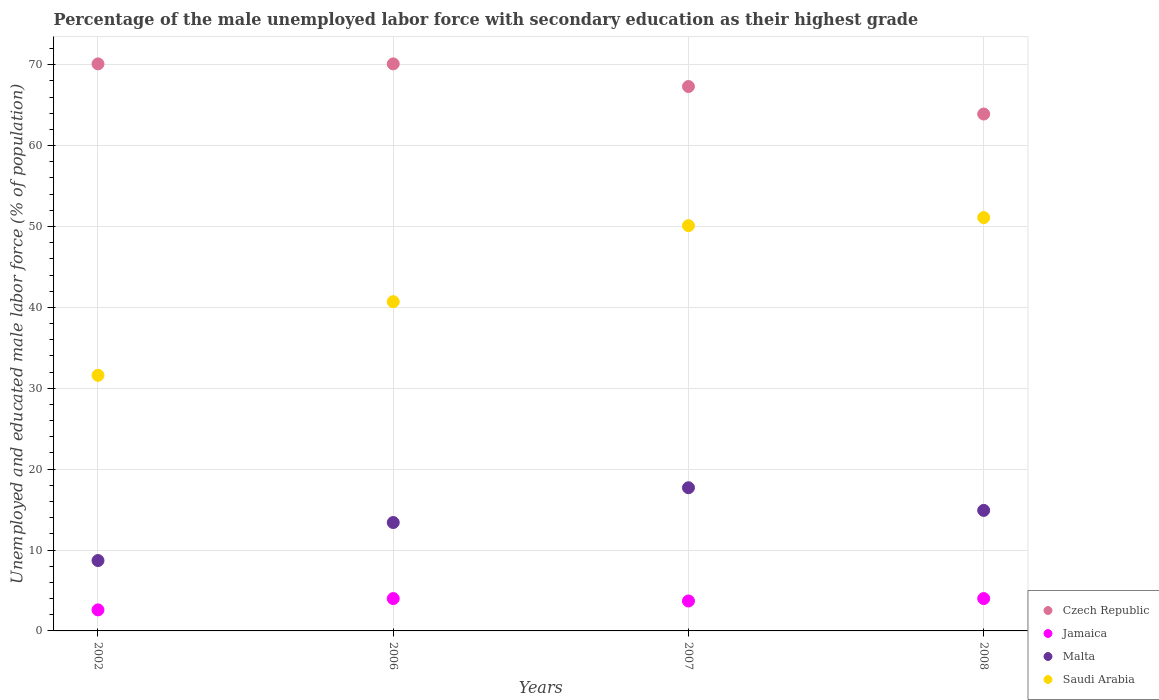What is the percentage of the unemployed male labor force with secondary education in Saudi Arabia in 2002?
Provide a succinct answer. 31.6. Across all years, what is the maximum percentage of the unemployed male labor force with secondary education in Czech Republic?
Your response must be concise. 70.1. Across all years, what is the minimum percentage of the unemployed male labor force with secondary education in Jamaica?
Ensure brevity in your answer.  2.6. In which year was the percentage of the unemployed male labor force with secondary education in Saudi Arabia minimum?
Your answer should be very brief. 2002. What is the total percentage of the unemployed male labor force with secondary education in Czech Republic in the graph?
Offer a terse response. 271.4. What is the difference between the percentage of the unemployed male labor force with secondary education in Malta in 2006 and that in 2008?
Ensure brevity in your answer.  -1.5. What is the difference between the percentage of the unemployed male labor force with secondary education in Czech Republic in 2007 and the percentage of the unemployed male labor force with secondary education in Malta in 2008?
Give a very brief answer. 52.4. What is the average percentage of the unemployed male labor force with secondary education in Czech Republic per year?
Offer a terse response. 67.85. In the year 2007, what is the difference between the percentage of the unemployed male labor force with secondary education in Malta and percentage of the unemployed male labor force with secondary education in Jamaica?
Offer a terse response. 14. In how many years, is the percentage of the unemployed male labor force with secondary education in Malta greater than 44 %?
Give a very brief answer. 0. What is the ratio of the percentage of the unemployed male labor force with secondary education in Jamaica in 2002 to that in 2008?
Your response must be concise. 0.65. What is the difference between the highest and the lowest percentage of the unemployed male labor force with secondary education in Malta?
Offer a terse response. 9. Is the percentage of the unemployed male labor force with secondary education in Malta strictly greater than the percentage of the unemployed male labor force with secondary education in Saudi Arabia over the years?
Provide a succinct answer. No. How many years are there in the graph?
Your answer should be very brief. 4. What is the difference between two consecutive major ticks on the Y-axis?
Ensure brevity in your answer.  10. Are the values on the major ticks of Y-axis written in scientific E-notation?
Your answer should be very brief. No. Where does the legend appear in the graph?
Your answer should be very brief. Bottom right. How many legend labels are there?
Offer a very short reply. 4. How are the legend labels stacked?
Keep it short and to the point. Vertical. What is the title of the graph?
Provide a short and direct response. Percentage of the male unemployed labor force with secondary education as their highest grade. What is the label or title of the Y-axis?
Ensure brevity in your answer.  Unemployed and educated male labor force (% of population). What is the Unemployed and educated male labor force (% of population) of Czech Republic in 2002?
Provide a short and direct response. 70.1. What is the Unemployed and educated male labor force (% of population) of Jamaica in 2002?
Make the answer very short. 2.6. What is the Unemployed and educated male labor force (% of population) of Malta in 2002?
Provide a short and direct response. 8.7. What is the Unemployed and educated male labor force (% of population) of Saudi Arabia in 2002?
Provide a succinct answer. 31.6. What is the Unemployed and educated male labor force (% of population) in Czech Republic in 2006?
Provide a succinct answer. 70.1. What is the Unemployed and educated male labor force (% of population) of Jamaica in 2006?
Provide a succinct answer. 4. What is the Unemployed and educated male labor force (% of population) in Malta in 2006?
Keep it short and to the point. 13.4. What is the Unemployed and educated male labor force (% of population) of Saudi Arabia in 2006?
Make the answer very short. 40.7. What is the Unemployed and educated male labor force (% of population) in Czech Republic in 2007?
Keep it short and to the point. 67.3. What is the Unemployed and educated male labor force (% of population) in Jamaica in 2007?
Your answer should be compact. 3.7. What is the Unemployed and educated male labor force (% of population) of Malta in 2007?
Your response must be concise. 17.7. What is the Unemployed and educated male labor force (% of population) of Saudi Arabia in 2007?
Provide a short and direct response. 50.1. What is the Unemployed and educated male labor force (% of population) of Czech Republic in 2008?
Offer a terse response. 63.9. What is the Unemployed and educated male labor force (% of population) in Malta in 2008?
Keep it short and to the point. 14.9. What is the Unemployed and educated male labor force (% of population) of Saudi Arabia in 2008?
Your response must be concise. 51.1. Across all years, what is the maximum Unemployed and educated male labor force (% of population) of Czech Republic?
Your answer should be compact. 70.1. Across all years, what is the maximum Unemployed and educated male labor force (% of population) in Jamaica?
Offer a very short reply. 4. Across all years, what is the maximum Unemployed and educated male labor force (% of population) in Malta?
Provide a succinct answer. 17.7. Across all years, what is the maximum Unemployed and educated male labor force (% of population) in Saudi Arabia?
Offer a very short reply. 51.1. Across all years, what is the minimum Unemployed and educated male labor force (% of population) in Czech Republic?
Ensure brevity in your answer.  63.9. Across all years, what is the minimum Unemployed and educated male labor force (% of population) of Jamaica?
Your response must be concise. 2.6. Across all years, what is the minimum Unemployed and educated male labor force (% of population) in Malta?
Provide a short and direct response. 8.7. Across all years, what is the minimum Unemployed and educated male labor force (% of population) of Saudi Arabia?
Your answer should be compact. 31.6. What is the total Unemployed and educated male labor force (% of population) of Czech Republic in the graph?
Your answer should be compact. 271.4. What is the total Unemployed and educated male labor force (% of population) in Malta in the graph?
Ensure brevity in your answer.  54.7. What is the total Unemployed and educated male labor force (% of population) in Saudi Arabia in the graph?
Give a very brief answer. 173.5. What is the difference between the Unemployed and educated male labor force (% of population) of Czech Republic in 2002 and that in 2006?
Offer a very short reply. 0. What is the difference between the Unemployed and educated male labor force (% of population) in Saudi Arabia in 2002 and that in 2006?
Give a very brief answer. -9.1. What is the difference between the Unemployed and educated male labor force (% of population) in Czech Republic in 2002 and that in 2007?
Give a very brief answer. 2.8. What is the difference between the Unemployed and educated male labor force (% of population) in Saudi Arabia in 2002 and that in 2007?
Your answer should be compact. -18.5. What is the difference between the Unemployed and educated male labor force (% of population) in Jamaica in 2002 and that in 2008?
Make the answer very short. -1.4. What is the difference between the Unemployed and educated male labor force (% of population) of Saudi Arabia in 2002 and that in 2008?
Keep it short and to the point. -19.5. What is the difference between the Unemployed and educated male labor force (% of population) in Czech Republic in 2006 and that in 2007?
Your answer should be very brief. 2.8. What is the difference between the Unemployed and educated male labor force (% of population) of Malta in 2006 and that in 2007?
Offer a very short reply. -4.3. What is the difference between the Unemployed and educated male labor force (% of population) of Saudi Arabia in 2006 and that in 2007?
Provide a short and direct response. -9.4. What is the difference between the Unemployed and educated male labor force (% of population) in Jamaica in 2007 and that in 2008?
Provide a succinct answer. -0.3. What is the difference between the Unemployed and educated male labor force (% of population) of Malta in 2007 and that in 2008?
Provide a short and direct response. 2.8. What is the difference between the Unemployed and educated male labor force (% of population) in Czech Republic in 2002 and the Unemployed and educated male labor force (% of population) in Jamaica in 2006?
Keep it short and to the point. 66.1. What is the difference between the Unemployed and educated male labor force (% of population) of Czech Republic in 2002 and the Unemployed and educated male labor force (% of population) of Malta in 2006?
Make the answer very short. 56.7. What is the difference between the Unemployed and educated male labor force (% of population) in Czech Republic in 2002 and the Unemployed and educated male labor force (% of population) in Saudi Arabia in 2006?
Offer a terse response. 29.4. What is the difference between the Unemployed and educated male labor force (% of population) in Jamaica in 2002 and the Unemployed and educated male labor force (% of population) in Saudi Arabia in 2006?
Offer a very short reply. -38.1. What is the difference between the Unemployed and educated male labor force (% of population) in Malta in 2002 and the Unemployed and educated male labor force (% of population) in Saudi Arabia in 2006?
Your answer should be compact. -32. What is the difference between the Unemployed and educated male labor force (% of population) in Czech Republic in 2002 and the Unemployed and educated male labor force (% of population) in Jamaica in 2007?
Your answer should be compact. 66.4. What is the difference between the Unemployed and educated male labor force (% of population) of Czech Republic in 2002 and the Unemployed and educated male labor force (% of population) of Malta in 2007?
Your answer should be compact. 52.4. What is the difference between the Unemployed and educated male labor force (% of population) in Czech Republic in 2002 and the Unemployed and educated male labor force (% of population) in Saudi Arabia in 2007?
Offer a very short reply. 20. What is the difference between the Unemployed and educated male labor force (% of population) in Jamaica in 2002 and the Unemployed and educated male labor force (% of population) in Malta in 2007?
Provide a short and direct response. -15.1. What is the difference between the Unemployed and educated male labor force (% of population) in Jamaica in 2002 and the Unemployed and educated male labor force (% of population) in Saudi Arabia in 2007?
Offer a terse response. -47.5. What is the difference between the Unemployed and educated male labor force (% of population) in Malta in 2002 and the Unemployed and educated male labor force (% of population) in Saudi Arabia in 2007?
Your response must be concise. -41.4. What is the difference between the Unemployed and educated male labor force (% of population) in Czech Republic in 2002 and the Unemployed and educated male labor force (% of population) in Jamaica in 2008?
Provide a short and direct response. 66.1. What is the difference between the Unemployed and educated male labor force (% of population) in Czech Republic in 2002 and the Unemployed and educated male labor force (% of population) in Malta in 2008?
Keep it short and to the point. 55.2. What is the difference between the Unemployed and educated male labor force (% of population) of Czech Republic in 2002 and the Unemployed and educated male labor force (% of population) of Saudi Arabia in 2008?
Your answer should be compact. 19. What is the difference between the Unemployed and educated male labor force (% of population) of Jamaica in 2002 and the Unemployed and educated male labor force (% of population) of Saudi Arabia in 2008?
Provide a short and direct response. -48.5. What is the difference between the Unemployed and educated male labor force (% of population) of Malta in 2002 and the Unemployed and educated male labor force (% of population) of Saudi Arabia in 2008?
Offer a very short reply. -42.4. What is the difference between the Unemployed and educated male labor force (% of population) in Czech Republic in 2006 and the Unemployed and educated male labor force (% of population) in Jamaica in 2007?
Your answer should be compact. 66.4. What is the difference between the Unemployed and educated male labor force (% of population) in Czech Republic in 2006 and the Unemployed and educated male labor force (% of population) in Malta in 2007?
Provide a short and direct response. 52.4. What is the difference between the Unemployed and educated male labor force (% of population) in Czech Republic in 2006 and the Unemployed and educated male labor force (% of population) in Saudi Arabia in 2007?
Make the answer very short. 20. What is the difference between the Unemployed and educated male labor force (% of population) in Jamaica in 2006 and the Unemployed and educated male labor force (% of population) in Malta in 2007?
Your answer should be compact. -13.7. What is the difference between the Unemployed and educated male labor force (% of population) in Jamaica in 2006 and the Unemployed and educated male labor force (% of population) in Saudi Arabia in 2007?
Offer a very short reply. -46.1. What is the difference between the Unemployed and educated male labor force (% of population) in Malta in 2006 and the Unemployed and educated male labor force (% of population) in Saudi Arabia in 2007?
Make the answer very short. -36.7. What is the difference between the Unemployed and educated male labor force (% of population) of Czech Republic in 2006 and the Unemployed and educated male labor force (% of population) of Jamaica in 2008?
Provide a succinct answer. 66.1. What is the difference between the Unemployed and educated male labor force (% of population) in Czech Republic in 2006 and the Unemployed and educated male labor force (% of population) in Malta in 2008?
Give a very brief answer. 55.2. What is the difference between the Unemployed and educated male labor force (% of population) of Czech Republic in 2006 and the Unemployed and educated male labor force (% of population) of Saudi Arabia in 2008?
Give a very brief answer. 19. What is the difference between the Unemployed and educated male labor force (% of population) in Jamaica in 2006 and the Unemployed and educated male labor force (% of population) in Saudi Arabia in 2008?
Your answer should be very brief. -47.1. What is the difference between the Unemployed and educated male labor force (% of population) in Malta in 2006 and the Unemployed and educated male labor force (% of population) in Saudi Arabia in 2008?
Offer a very short reply. -37.7. What is the difference between the Unemployed and educated male labor force (% of population) in Czech Republic in 2007 and the Unemployed and educated male labor force (% of population) in Jamaica in 2008?
Your answer should be compact. 63.3. What is the difference between the Unemployed and educated male labor force (% of population) in Czech Republic in 2007 and the Unemployed and educated male labor force (% of population) in Malta in 2008?
Provide a succinct answer. 52.4. What is the difference between the Unemployed and educated male labor force (% of population) in Czech Republic in 2007 and the Unemployed and educated male labor force (% of population) in Saudi Arabia in 2008?
Give a very brief answer. 16.2. What is the difference between the Unemployed and educated male labor force (% of population) of Jamaica in 2007 and the Unemployed and educated male labor force (% of population) of Malta in 2008?
Offer a very short reply. -11.2. What is the difference between the Unemployed and educated male labor force (% of population) of Jamaica in 2007 and the Unemployed and educated male labor force (% of population) of Saudi Arabia in 2008?
Your answer should be compact. -47.4. What is the difference between the Unemployed and educated male labor force (% of population) of Malta in 2007 and the Unemployed and educated male labor force (% of population) of Saudi Arabia in 2008?
Your answer should be compact. -33.4. What is the average Unemployed and educated male labor force (% of population) in Czech Republic per year?
Give a very brief answer. 67.85. What is the average Unemployed and educated male labor force (% of population) of Jamaica per year?
Offer a very short reply. 3.58. What is the average Unemployed and educated male labor force (% of population) of Malta per year?
Make the answer very short. 13.68. What is the average Unemployed and educated male labor force (% of population) in Saudi Arabia per year?
Provide a succinct answer. 43.38. In the year 2002, what is the difference between the Unemployed and educated male labor force (% of population) in Czech Republic and Unemployed and educated male labor force (% of population) in Jamaica?
Make the answer very short. 67.5. In the year 2002, what is the difference between the Unemployed and educated male labor force (% of population) of Czech Republic and Unemployed and educated male labor force (% of population) of Malta?
Make the answer very short. 61.4. In the year 2002, what is the difference between the Unemployed and educated male labor force (% of population) in Czech Republic and Unemployed and educated male labor force (% of population) in Saudi Arabia?
Your answer should be very brief. 38.5. In the year 2002, what is the difference between the Unemployed and educated male labor force (% of population) in Malta and Unemployed and educated male labor force (% of population) in Saudi Arabia?
Ensure brevity in your answer.  -22.9. In the year 2006, what is the difference between the Unemployed and educated male labor force (% of population) in Czech Republic and Unemployed and educated male labor force (% of population) in Jamaica?
Offer a terse response. 66.1. In the year 2006, what is the difference between the Unemployed and educated male labor force (% of population) of Czech Republic and Unemployed and educated male labor force (% of population) of Malta?
Ensure brevity in your answer.  56.7. In the year 2006, what is the difference between the Unemployed and educated male labor force (% of population) of Czech Republic and Unemployed and educated male labor force (% of population) of Saudi Arabia?
Provide a succinct answer. 29.4. In the year 2006, what is the difference between the Unemployed and educated male labor force (% of population) in Jamaica and Unemployed and educated male labor force (% of population) in Malta?
Keep it short and to the point. -9.4. In the year 2006, what is the difference between the Unemployed and educated male labor force (% of population) in Jamaica and Unemployed and educated male labor force (% of population) in Saudi Arabia?
Provide a short and direct response. -36.7. In the year 2006, what is the difference between the Unemployed and educated male labor force (% of population) in Malta and Unemployed and educated male labor force (% of population) in Saudi Arabia?
Make the answer very short. -27.3. In the year 2007, what is the difference between the Unemployed and educated male labor force (% of population) of Czech Republic and Unemployed and educated male labor force (% of population) of Jamaica?
Provide a short and direct response. 63.6. In the year 2007, what is the difference between the Unemployed and educated male labor force (% of population) in Czech Republic and Unemployed and educated male labor force (% of population) in Malta?
Offer a terse response. 49.6. In the year 2007, what is the difference between the Unemployed and educated male labor force (% of population) in Czech Republic and Unemployed and educated male labor force (% of population) in Saudi Arabia?
Provide a short and direct response. 17.2. In the year 2007, what is the difference between the Unemployed and educated male labor force (% of population) in Jamaica and Unemployed and educated male labor force (% of population) in Malta?
Ensure brevity in your answer.  -14. In the year 2007, what is the difference between the Unemployed and educated male labor force (% of population) of Jamaica and Unemployed and educated male labor force (% of population) of Saudi Arabia?
Give a very brief answer. -46.4. In the year 2007, what is the difference between the Unemployed and educated male labor force (% of population) of Malta and Unemployed and educated male labor force (% of population) of Saudi Arabia?
Give a very brief answer. -32.4. In the year 2008, what is the difference between the Unemployed and educated male labor force (% of population) of Czech Republic and Unemployed and educated male labor force (% of population) of Jamaica?
Give a very brief answer. 59.9. In the year 2008, what is the difference between the Unemployed and educated male labor force (% of population) of Czech Republic and Unemployed and educated male labor force (% of population) of Malta?
Give a very brief answer. 49. In the year 2008, what is the difference between the Unemployed and educated male labor force (% of population) of Jamaica and Unemployed and educated male labor force (% of population) of Malta?
Offer a very short reply. -10.9. In the year 2008, what is the difference between the Unemployed and educated male labor force (% of population) of Jamaica and Unemployed and educated male labor force (% of population) of Saudi Arabia?
Ensure brevity in your answer.  -47.1. In the year 2008, what is the difference between the Unemployed and educated male labor force (% of population) of Malta and Unemployed and educated male labor force (% of population) of Saudi Arabia?
Provide a short and direct response. -36.2. What is the ratio of the Unemployed and educated male labor force (% of population) of Jamaica in 2002 to that in 2006?
Your response must be concise. 0.65. What is the ratio of the Unemployed and educated male labor force (% of population) of Malta in 2002 to that in 2006?
Offer a very short reply. 0.65. What is the ratio of the Unemployed and educated male labor force (% of population) in Saudi Arabia in 2002 to that in 2006?
Your answer should be compact. 0.78. What is the ratio of the Unemployed and educated male labor force (% of population) of Czech Republic in 2002 to that in 2007?
Provide a succinct answer. 1.04. What is the ratio of the Unemployed and educated male labor force (% of population) in Jamaica in 2002 to that in 2007?
Your response must be concise. 0.7. What is the ratio of the Unemployed and educated male labor force (% of population) in Malta in 2002 to that in 2007?
Give a very brief answer. 0.49. What is the ratio of the Unemployed and educated male labor force (% of population) of Saudi Arabia in 2002 to that in 2007?
Your answer should be compact. 0.63. What is the ratio of the Unemployed and educated male labor force (% of population) in Czech Republic in 2002 to that in 2008?
Provide a short and direct response. 1.1. What is the ratio of the Unemployed and educated male labor force (% of population) in Jamaica in 2002 to that in 2008?
Give a very brief answer. 0.65. What is the ratio of the Unemployed and educated male labor force (% of population) of Malta in 2002 to that in 2008?
Your answer should be compact. 0.58. What is the ratio of the Unemployed and educated male labor force (% of population) in Saudi Arabia in 2002 to that in 2008?
Ensure brevity in your answer.  0.62. What is the ratio of the Unemployed and educated male labor force (% of population) in Czech Republic in 2006 to that in 2007?
Give a very brief answer. 1.04. What is the ratio of the Unemployed and educated male labor force (% of population) in Jamaica in 2006 to that in 2007?
Keep it short and to the point. 1.08. What is the ratio of the Unemployed and educated male labor force (% of population) of Malta in 2006 to that in 2007?
Offer a terse response. 0.76. What is the ratio of the Unemployed and educated male labor force (% of population) in Saudi Arabia in 2006 to that in 2007?
Provide a short and direct response. 0.81. What is the ratio of the Unemployed and educated male labor force (% of population) of Czech Republic in 2006 to that in 2008?
Your response must be concise. 1.1. What is the ratio of the Unemployed and educated male labor force (% of population) of Jamaica in 2006 to that in 2008?
Give a very brief answer. 1. What is the ratio of the Unemployed and educated male labor force (% of population) of Malta in 2006 to that in 2008?
Make the answer very short. 0.9. What is the ratio of the Unemployed and educated male labor force (% of population) of Saudi Arabia in 2006 to that in 2008?
Give a very brief answer. 0.8. What is the ratio of the Unemployed and educated male labor force (% of population) of Czech Republic in 2007 to that in 2008?
Make the answer very short. 1.05. What is the ratio of the Unemployed and educated male labor force (% of population) of Jamaica in 2007 to that in 2008?
Your answer should be very brief. 0.93. What is the ratio of the Unemployed and educated male labor force (% of population) in Malta in 2007 to that in 2008?
Keep it short and to the point. 1.19. What is the ratio of the Unemployed and educated male labor force (% of population) of Saudi Arabia in 2007 to that in 2008?
Keep it short and to the point. 0.98. What is the difference between the highest and the lowest Unemployed and educated male labor force (% of population) of Czech Republic?
Keep it short and to the point. 6.2. What is the difference between the highest and the lowest Unemployed and educated male labor force (% of population) in Malta?
Make the answer very short. 9. What is the difference between the highest and the lowest Unemployed and educated male labor force (% of population) in Saudi Arabia?
Offer a very short reply. 19.5. 